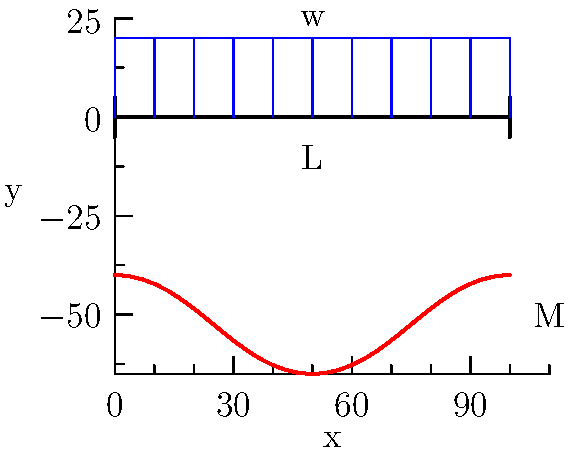In the context of social structures and their impact on psychological well-being, consider a beam of length L subjected to a uniformly distributed load w. How does the bending moment distribution relate to the concept of stress in society, and at which point along the beam is the maximum bending moment experienced? To understand this problem, let's break it down into steps that relate mechanical engineering concepts to sociological perspectives:

1. Beam analogy: The beam represents a social structure, while the distributed load represents the various pressures and demands placed on society.

2. Bending moment distribution: In mechanical terms, the bending moment M at any point x along the beam is given by:

   $$M(x) = \frac{wx}{2}(L-x)$$

   This parabolic distribution can be seen as analogous to how stress is distributed across different segments of society.

3. Maximum bending moment: To find the location of maximum bending moment, we differentiate M(x) with respect to x and set it to zero:

   $$\frac{dM}{dx} = \frac{w}{2}(L-2x) = 0$$

   Solving this equation:
   $$L-2x = 0$$
   $$x = \frac{L}{2}$$

4. Sociological interpretation: The point of maximum bending moment (x = L/2) represents the segment of society that bears the most stress or pressure. This could be related to concepts like the "squeezed middle class" or the group most affected by societal changes.

5. Value of maximum bending moment: Substituting x = L/2 into the bending moment equation:

   $$M_{max} = \frac{wL}{2}(\frac{L}{2}) = \frac{wL^2}{8}$$

   This represents the peak stress experienced in the social structure.

6. Stress distribution: The parabolic shape of the bending moment diagram illustrates how stress is not uniformly distributed across society, with some segments experiencing more pressure than others.
Answer: The maximum bending moment occurs at the middle of the beam (x = L/2), analogous to the segment of society bearing the most stress. 